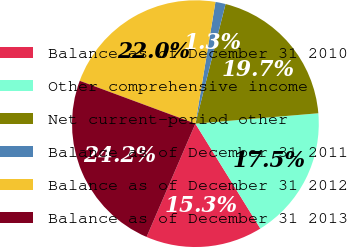<chart> <loc_0><loc_0><loc_500><loc_500><pie_chart><fcel>Balance as of December 31 2010<fcel>Other comprehensive income<fcel>Net current-period other<fcel>Balance as of December 31 2011<fcel>Balance as of December 31 2012<fcel>Balance as of December 31 2013<nl><fcel>15.3%<fcel>17.52%<fcel>19.73%<fcel>1.33%<fcel>21.95%<fcel>24.17%<nl></chart> 